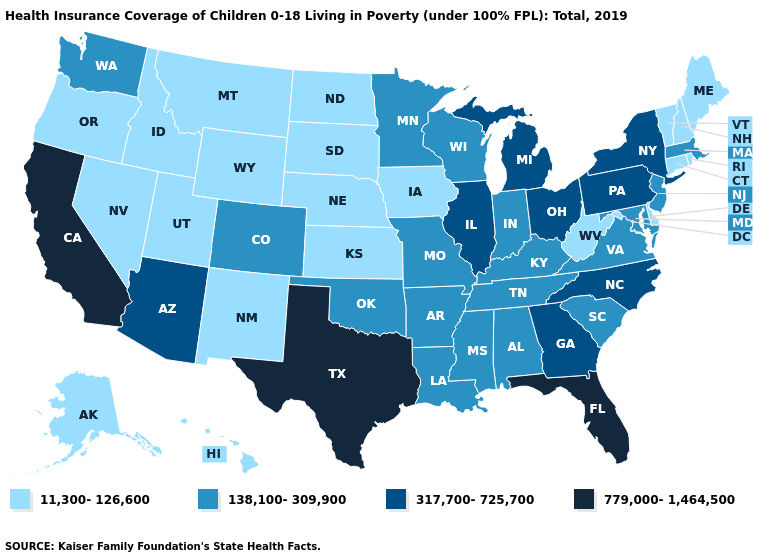Among the states that border Tennessee , which have the highest value?
Concise answer only. Georgia, North Carolina. Does California have the highest value in the USA?
Quick response, please. Yes. Does Utah have the lowest value in the USA?
Quick response, please. Yes. Name the states that have a value in the range 317,700-725,700?
Quick response, please. Arizona, Georgia, Illinois, Michigan, New York, North Carolina, Ohio, Pennsylvania. Does Georgia have the same value as North Carolina?
Short answer required. Yes. Does the first symbol in the legend represent the smallest category?
Answer briefly. Yes. Which states have the lowest value in the USA?
Short answer required. Alaska, Connecticut, Delaware, Hawaii, Idaho, Iowa, Kansas, Maine, Montana, Nebraska, Nevada, New Hampshire, New Mexico, North Dakota, Oregon, Rhode Island, South Dakota, Utah, Vermont, West Virginia, Wyoming. Does Massachusetts have a lower value than Mississippi?
Give a very brief answer. No. What is the value of Nebraska?
Answer briefly. 11,300-126,600. Does Louisiana have the highest value in the USA?
Answer briefly. No. What is the value of Utah?
Write a very short answer. 11,300-126,600. Does Texas have the highest value in the USA?
Quick response, please. Yes. Name the states that have a value in the range 779,000-1,464,500?
Concise answer only. California, Florida, Texas. Name the states that have a value in the range 11,300-126,600?
Keep it brief. Alaska, Connecticut, Delaware, Hawaii, Idaho, Iowa, Kansas, Maine, Montana, Nebraska, Nevada, New Hampshire, New Mexico, North Dakota, Oregon, Rhode Island, South Dakota, Utah, Vermont, West Virginia, Wyoming. Name the states that have a value in the range 779,000-1,464,500?
Quick response, please. California, Florida, Texas. 